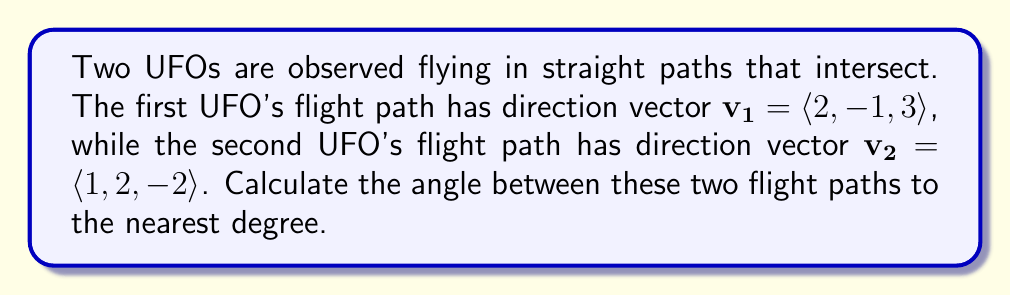Could you help me with this problem? To find the angle between two vectors, we can use the dot product formula:

$$\cos \theta = \frac{\mathbf{v_1} \cdot \mathbf{v_2}}{|\mathbf{v_1}||\mathbf{v_2}|}$$

Step 1: Calculate the dot product $\mathbf{v_1} \cdot \mathbf{v_2}$
$$\mathbf{v_1} \cdot \mathbf{v_2} = (2)(1) + (-1)(2) + (3)(-2) = 2 - 2 - 6 = -6$$

Step 2: Calculate the magnitudes of the vectors
$$|\mathbf{v_1}| = \sqrt{2^2 + (-1)^2 + 3^2} = \sqrt{4 + 1 + 9} = \sqrt{14}$$
$$|\mathbf{v_2}| = \sqrt{1^2 + 2^2 + (-2)^2} = \sqrt{1 + 4 + 4} = 3$$

Step 3: Substitute into the formula
$$\cos \theta = \frac{-6}{\sqrt{14} \cdot 3} = \frac{-6}{3\sqrt{14}}$$

Step 4: Take the inverse cosine (arccos) of both sides
$$\theta = \arccos\left(\frac{-6}{3\sqrt{14}}\right)$$

Step 5: Calculate the result and round to the nearest degree
$$\theta \approx 116.57° \approx 117°$$
Answer: 117° 